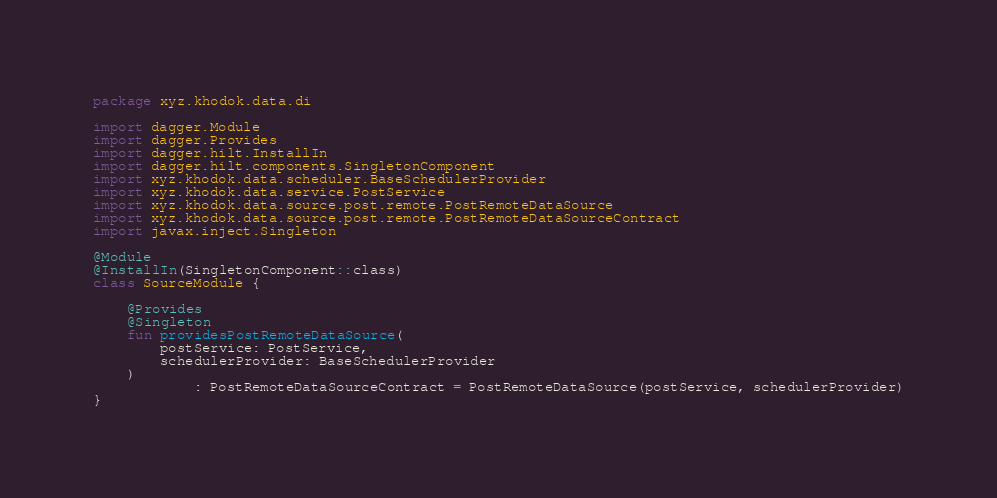<code> <loc_0><loc_0><loc_500><loc_500><_Kotlin_>package xyz.khodok.data.di

import dagger.Module
import dagger.Provides
import dagger.hilt.InstallIn
import dagger.hilt.components.SingletonComponent
import xyz.khodok.data.scheduler.BaseSchedulerProvider
import xyz.khodok.data.service.PostService
import xyz.khodok.data.source.post.remote.PostRemoteDataSource
import xyz.khodok.data.source.post.remote.PostRemoteDataSourceContract
import javax.inject.Singleton

@Module
@InstallIn(SingletonComponent::class)
class SourceModule {

    @Provides
    @Singleton
    fun providesPostRemoteDataSource(
        postService: PostService,
        schedulerProvider: BaseSchedulerProvider
    )
            : PostRemoteDataSourceContract = PostRemoteDataSource(postService, schedulerProvider)
}
</code> 